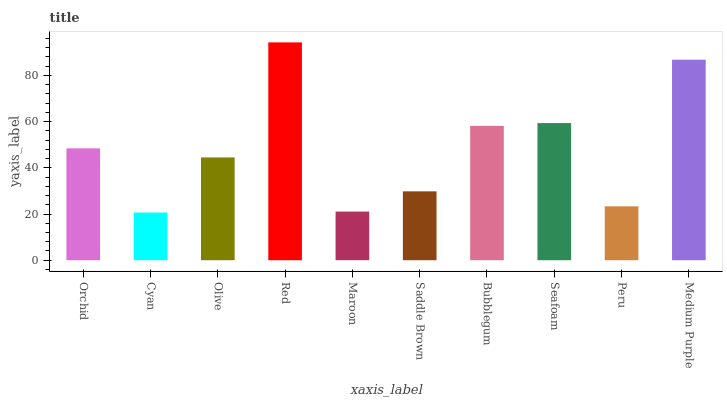Is Cyan the minimum?
Answer yes or no. Yes. Is Red the maximum?
Answer yes or no. Yes. Is Olive the minimum?
Answer yes or no. No. Is Olive the maximum?
Answer yes or no. No. Is Olive greater than Cyan?
Answer yes or no. Yes. Is Cyan less than Olive?
Answer yes or no. Yes. Is Cyan greater than Olive?
Answer yes or no. No. Is Olive less than Cyan?
Answer yes or no. No. Is Orchid the high median?
Answer yes or no. Yes. Is Olive the low median?
Answer yes or no. Yes. Is Saddle Brown the high median?
Answer yes or no. No. Is Saddle Brown the low median?
Answer yes or no. No. 